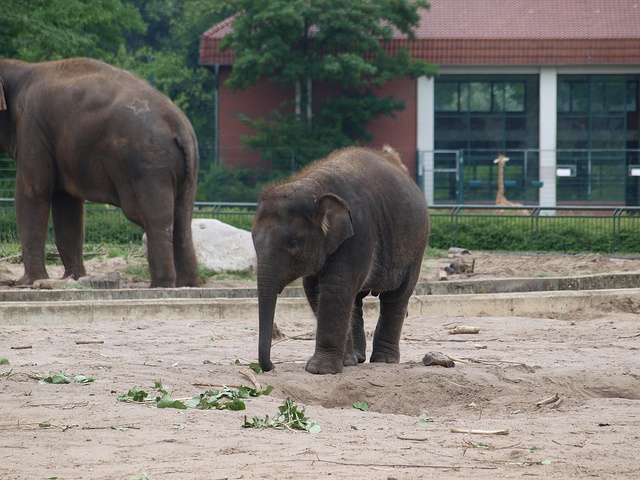Describe the objects in this image and their specific colors. I can see elephant in darkgreen, black, and gray tones, elephant in darkgreen, black, gray, and darkgray tones, and giraffe in darkgreen, gray, and darkgray tones in this image. 